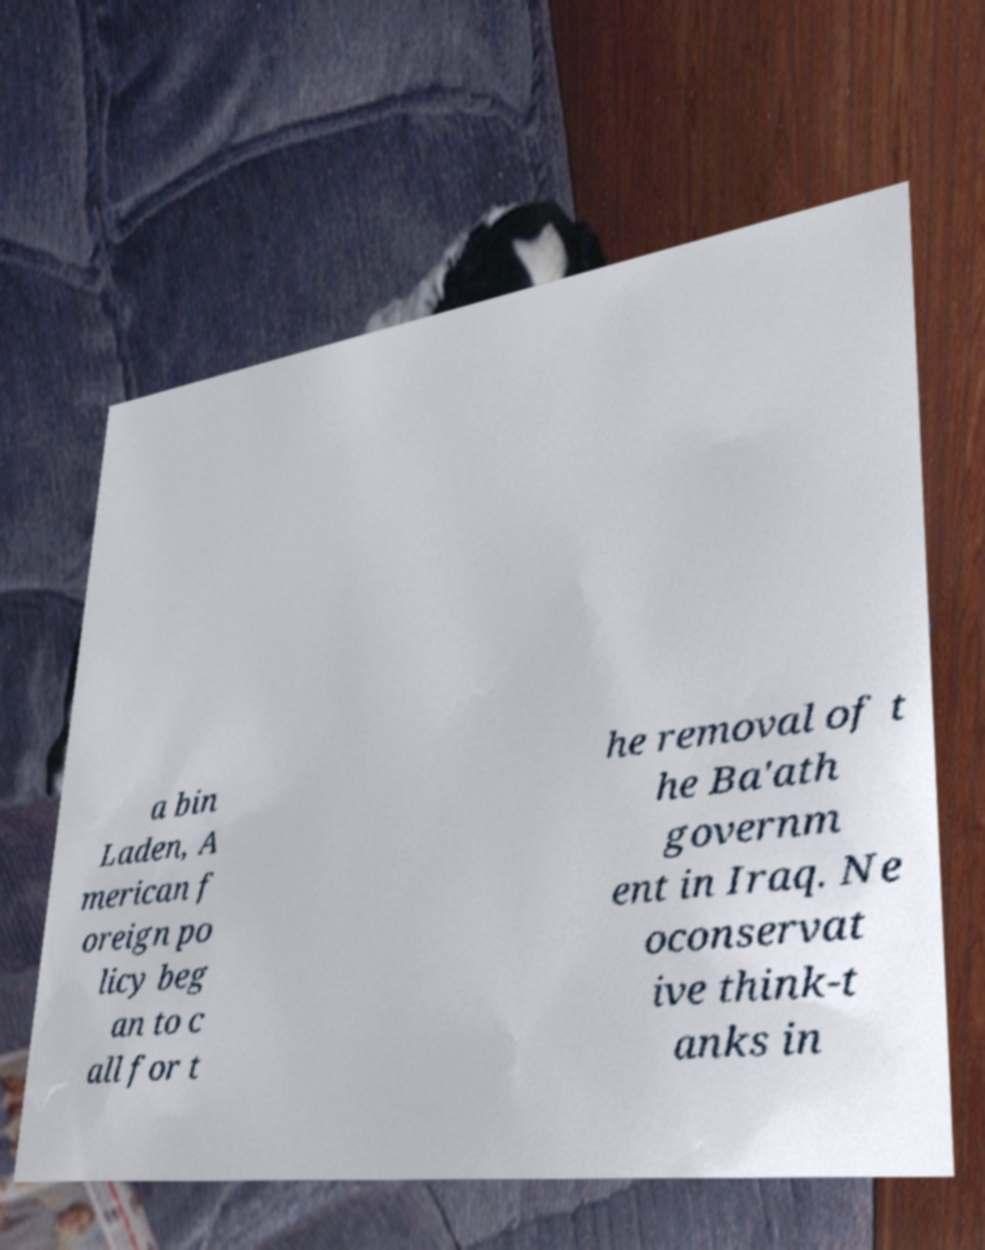Please read and relay the text visible in this image. What does it say? a bin Laden, A merican f oreign po licy beg an to c all for t he removal of t he Ba'ath governm ent in Iraq. Ne oconservat ive think-t anks in 